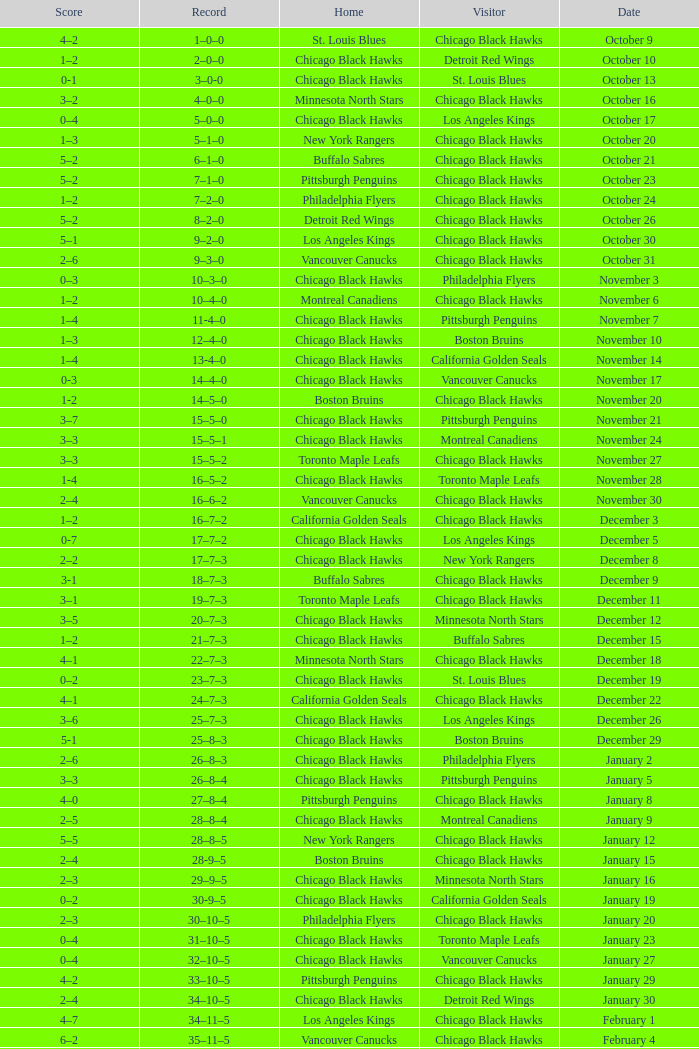What is the Score of the Chicago Black Hawks Home game with the Visiting Vancouver Canucks on November 17? 0-3. 